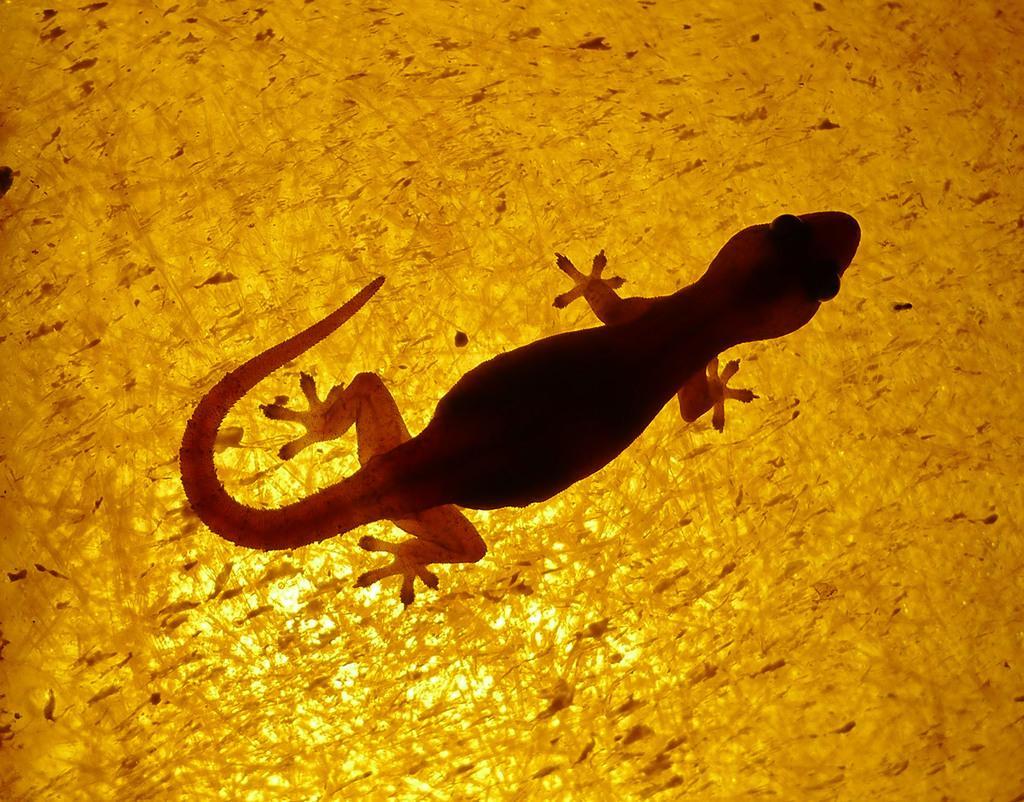Describe this image in one or two sentences. This image consists of a lizard on a surface. 